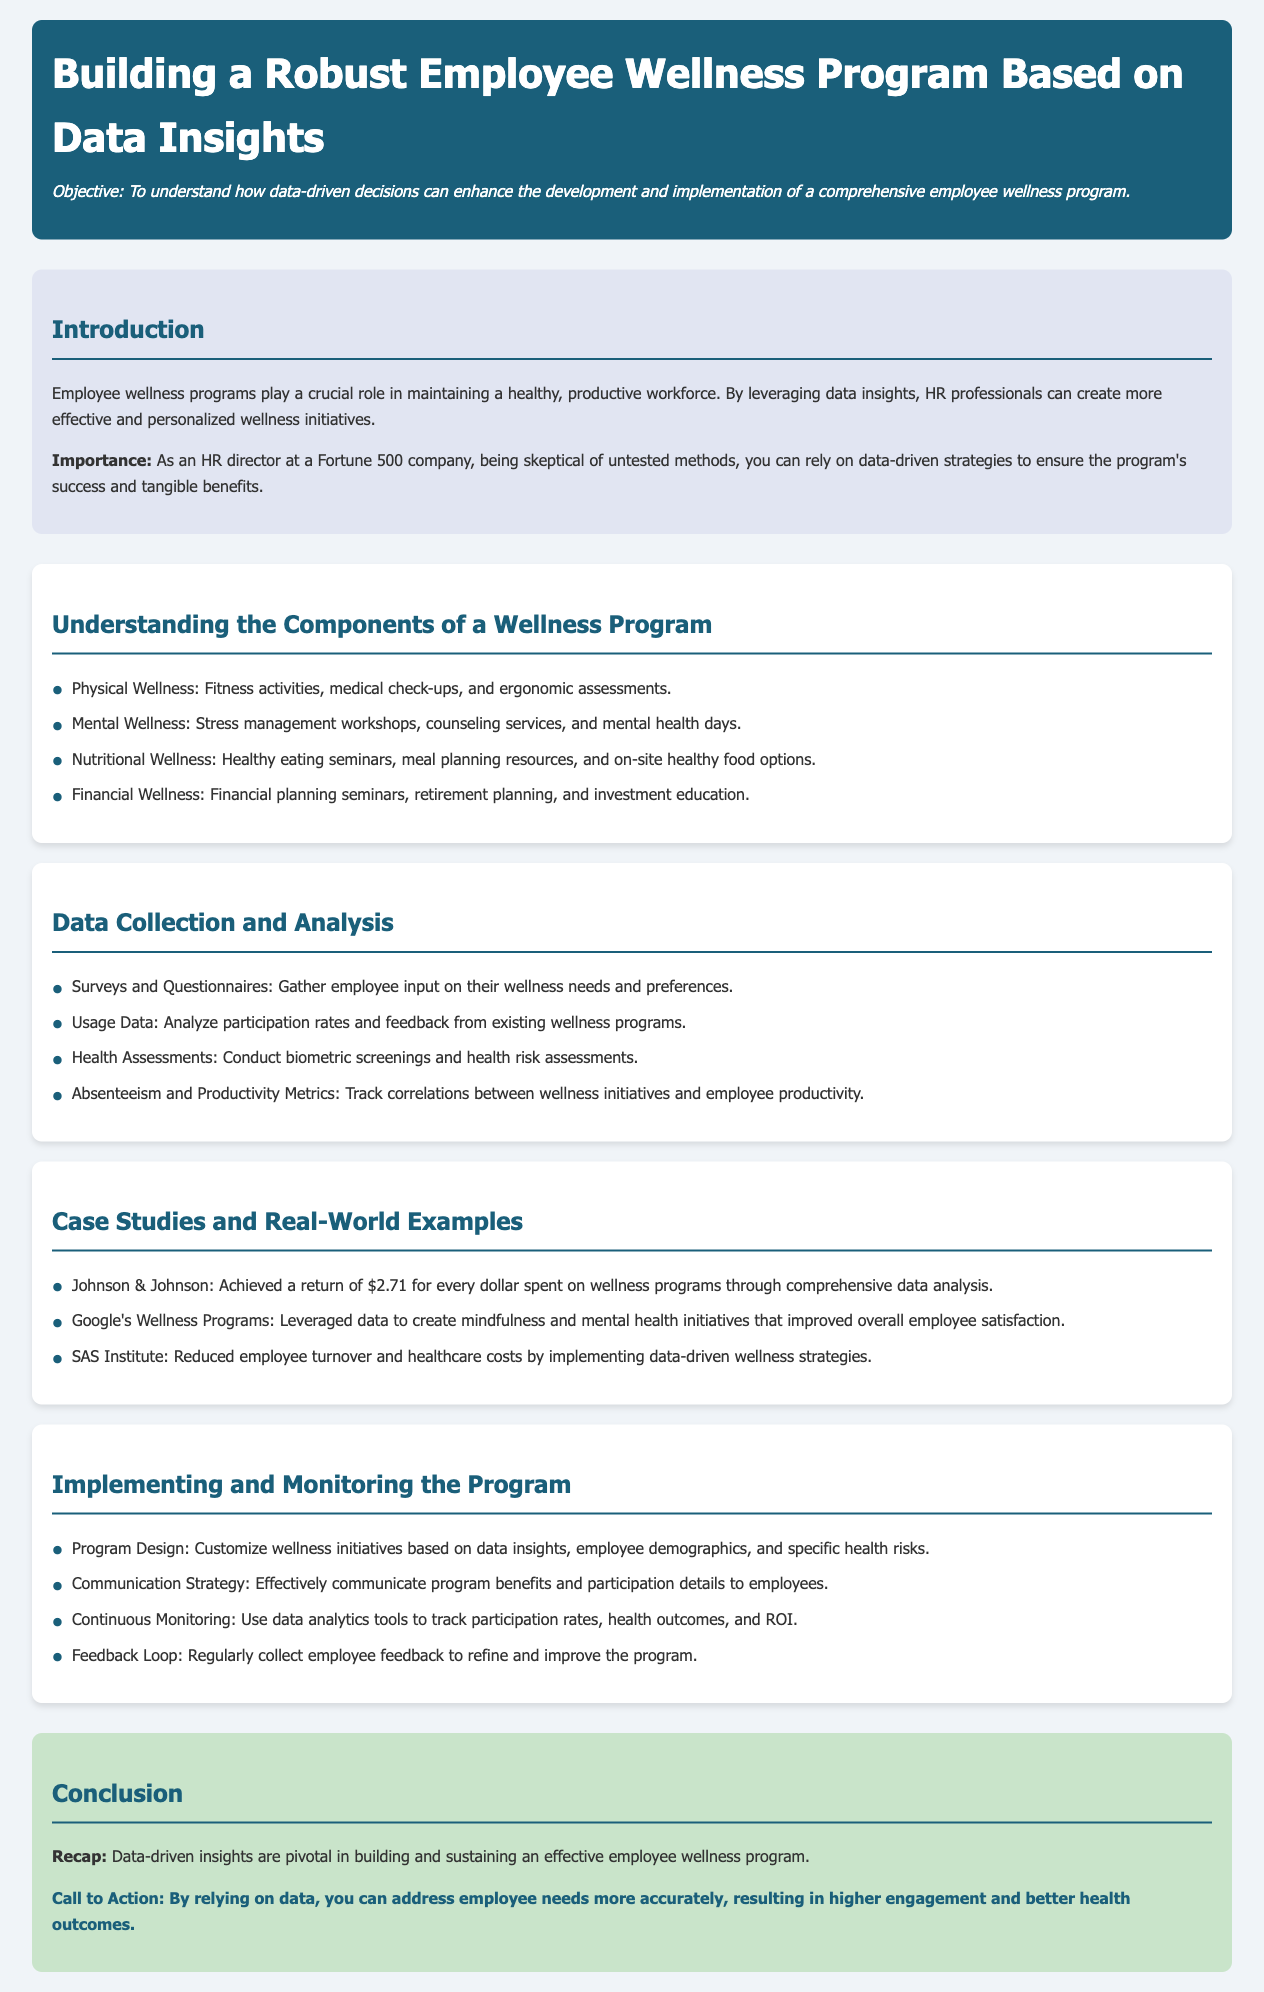What is the objective of the lesson plan? The objective is to understand how data-driven decisions can enhance the development and implementation of a comprehensive employee wellness program.
Answer: To understand how data-driven decisions can enhance the development and implementation of a comprehensive employee wellness program What components are included in the wellness program? The document lists four components of a wellness program: physical, mental, nutritional, and financial wellness.
Answer: Physical, Mental, Nutritional, Financial Which company achieved a return of $2.71 for every dollar spent on wellness programs? Johnson & Johnson is mentioned as achieving this return through comprehensive data analysis.
Answer: Johnson & Johnson What method is suggested for gathering employee input on their wellness needs? Surveys and questionnaires are recommended for gathering input from employees.
Answer: Surveys and Questionnaires What is one suggested strategy for program implementation? Customizing wellness initiatives based on data insights is one of the suggested strategies for implementation.
Answer: Customize wellness initiatives based on data insights What is the color of the header section in the document? The header section is described to have a background color of #1a5f7a.
Answer: #1a5f7a What is a key aspect of the continuous monitoring process? The document mentions using data analytics tools to track participation rates as a key aspect.
Answer: Data analytics tools to track participation rates What type of programs did Google's wellness initiatives focus on? Google’s wellness initiatives specifically focused on mindfulness and mental health.
Answer: Mindfulness and mental health 